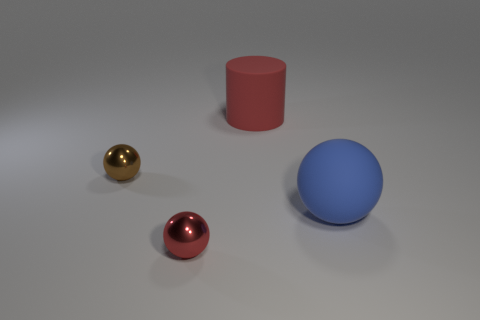Add 3 yellow matte cubes. How many objects exist? 7 Subtract all spheres. How many objects are left? 1 Add 2 large red cylinders. How many large red cylinders are left? 3 Add 1 small cyan things. How many small cyan things exist? 1 Subtract 0 purple cylinders. How many objects are left? 4 Subtract all blue things. Subtract all tiny brown balls. How many objects are left? 2 